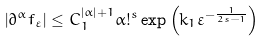<formula> <loc_0><loc_0><loc_500><loc_500>\left | \partial ^ { \alpha } f _ { \varepsilon } \right | \leq C _ { 1 } ^ { \left | \alpha \right | + 1 } \alpha ! ^ { s } \exp \left ( k _ { 1 } \varepsilon ^ { - \frac { 1 } { 2 s - 1 } } \right )</formula> 